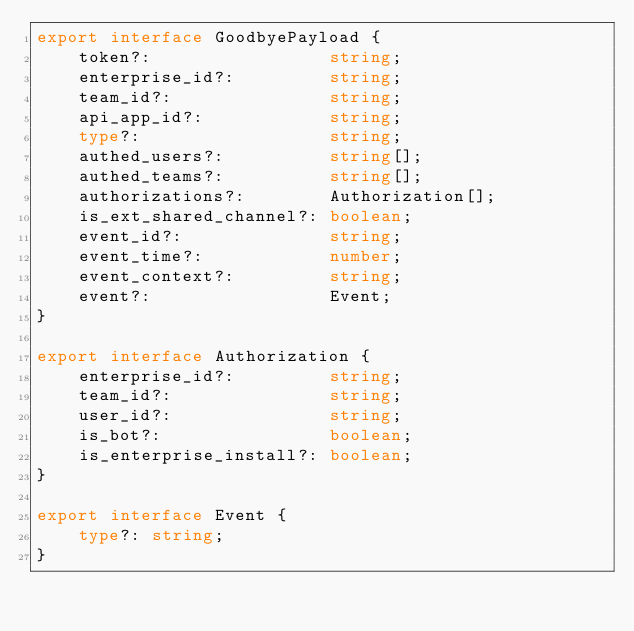<code> <loc_0><loc_0><loc_500><loc_500><_TypeScript_>export interface GoodbyePayload {
    token?:                 string;
    enterprise_id?:         string;
    team_id?:               string;
    api_app_id?:            string;
    type?:                  string;
    authed_users?:          string[];
    authed_teams?:          string[];
    authorizations?:        Authorization[];
    is_ext_shared_channel?: boolean;
    event_id?:              string;
    event_time?:            number;
    event_context?:         string;
    event?:                 Event;
}

export interface Authorization {
    enterprise_id?:         string;
    team_id?:               string;
    user_id?:               string;
    is_bot?:                boolean;
    is_enterprise_install?: boolean;
}

export interface Event {
    type?: string;
}
</code> 